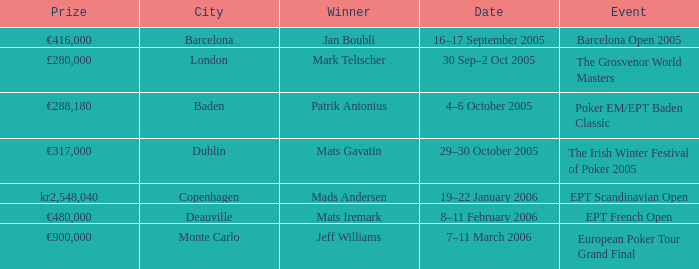Would you mind parsing the complete table? {'header': ['Prize', 'City', 'Winner', 'Date', 'Event'], 'rows': [['€416,000', 'Barcelona', 'Jan Boubli', '16–17 September 2005', 'Barcelona Open 2005'], ['£280,000', 'London', 'Mark Teltscher', '30 Sep–2 Oct 2005', 'The Grosvenor World Masters'], ['€288,180', 'Baden', 'Patrik Antonius', '4–6 October 2005', 'Poker EM/EPT Baden Classic'], ['€317,000', 'Dublin', 'Mats Gavatin', '29–30 October 2005', 'The Irish Winter Festival of Poker 2005'], ['kr2,548,040', 'Copenhagen', 'Mads Andersen', '19–22 January 2006', 'EPT Scandinavian Open'], ['€480,000', 'Deauville', 'Mats Iremark', '8–11 February 2006', 'EPT French Open'], ['€900,000', 'Monte Carlo', 'Jeff Williams', '7–11 March 2006', 'European Poker Tour Grand Final']]} When was the event in the City of Baden? 4–6 October 2005. 